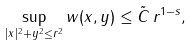Convert formula to latex. <formula><loc_0><loc_0><loc_500><loc_500>\sup _ { | x | ^ { 2 } + y ^ { 2 } \leq r ^ { 2 } } w ( x , y ) \leq \tilde { C } \, r ^ { 1 - s } ,</formula> 